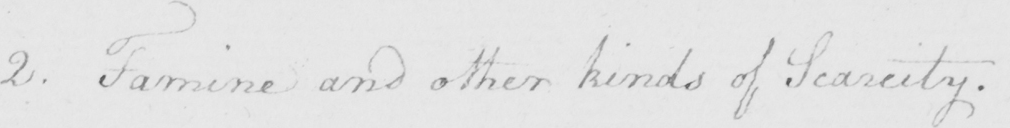Please provide the text content of this handwritten line. 2 . Famine and other kinds of Scarcity . 